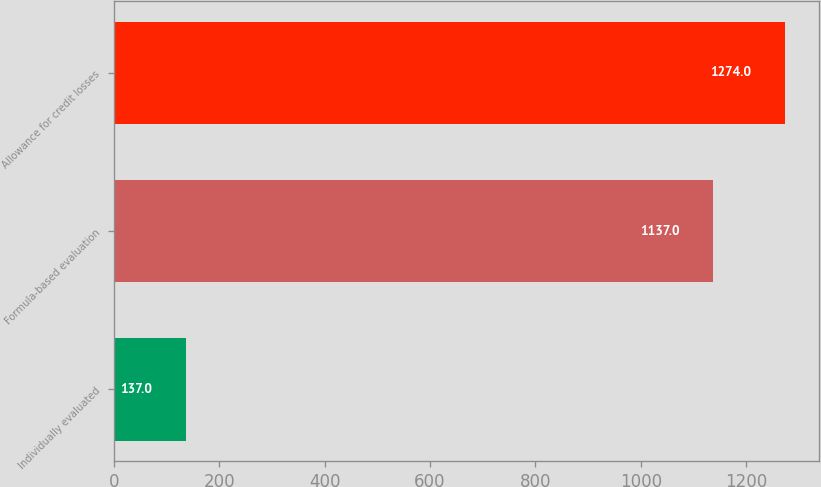Convert chart to OTSL. <chart><loc_0><loc_0><loc_500><loc_500><bar_chart><fcel>Individually evaluated<fcel>Formula-based evaluation<fcel>Allowance for credit losses<nl><fcel>137<fcel>1137<fcel>1274<nl></chart> 